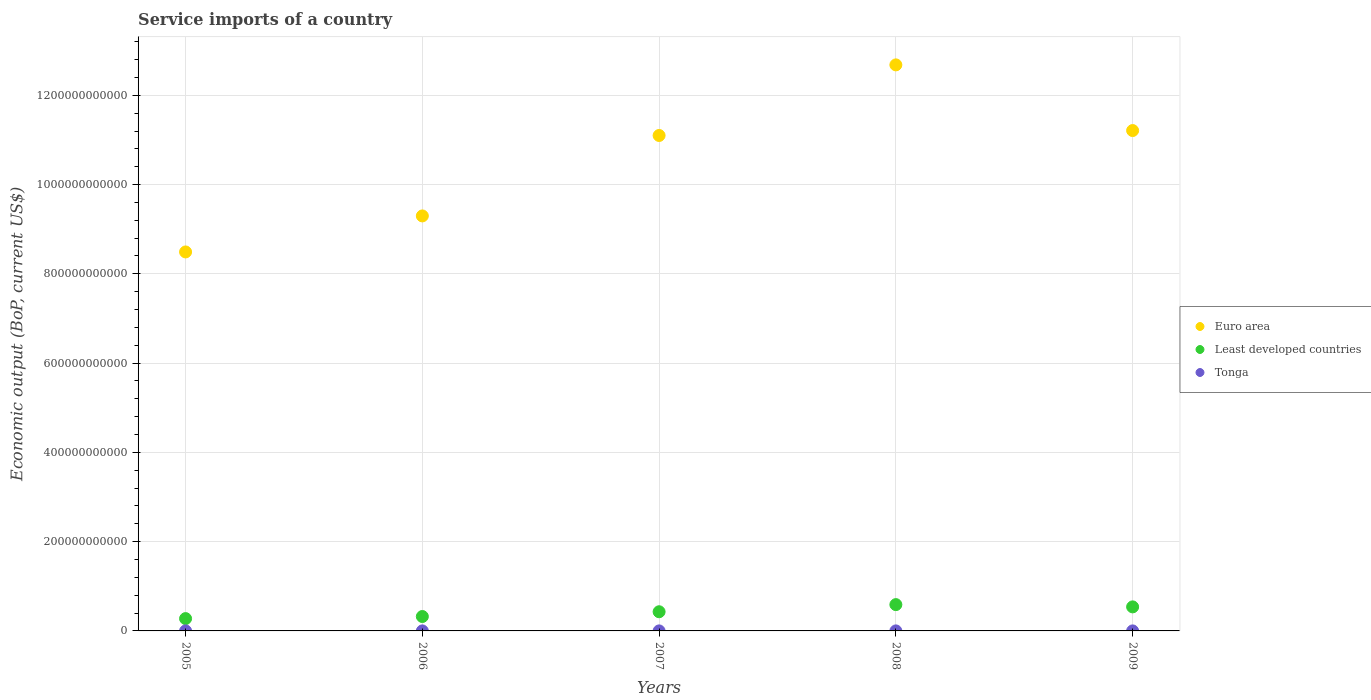What is the service imports in Tonga in 2006?
Make the answer very short. 3.78e+07. Across all years, what is the maximum service imports in Least developed countries?
Your answer should be very brief. 5.89e+1. Across all years, what is the minimum service imports in Least developed countries?
Make the answer very short. 2.76e+1. What is the total service imports in Euro area in the graph?
Offer a terse response. 5.28e+12. What is the difference between the service imports in Euro area in 2005 and that in 2009?
Your answer should be compact. -2.72e+11. What is the difference between the service imports in Euro area in 2006 and the service imports in Tonga in 2008?
Offer a very short reply. 9.30e+11. What is the average service imports in Tonga per year?
Keep it short and to the point. 4.65e+07. In the year 2009, what is the difference between the service imports in Euro area and service imports in Least developed countries?
Your answer should be compact. 1.07e+12. What is the ratio of the service imports in Least developed countries in 2005 to that in 2009?
Keep it short and to the point. 0.51. What is the difference between the highest and the second highest service imports in Euro area?
Offer a very short reply. 1.47e+11. What is the difference between the highest and the lowest service imports in Least developed countries?
Make the answer very short. 3.13e+1. In how many years, is the service imports in Euro area greater than the average service imports in Euro area taken over all years?
Make the answer very short. 3. Is the sum of the service imports in Euro area in 2005 and 2007 greater than the maximum service imports in Least developed countries across all years?
Offer a very short reply. Yes. Does the service imports in Euro area monotonically increase over the years?
Provide a succinct answer. No. Is the service imports in Tonga strictly greater than the service imports in Euro area over the years?
Offer a terse response. No. Is the service imports in Least developed countries strictly less than the service imports in Tonga over the years?
Keep it short and to the point. No. How many dotlines are there?
Your response must be concise. 3. How many years are there in the graph?
Provide a succinct answer. 5. What is the difference between two consecutive major ticks on the Y-axis?
Keep it short and to the point. 2.00e+11. Does the graph contain grids?
Your response must be concise. Yes. Where does the legend appear in the graph?
Keep it short and to the point. Center right. How many legend labels are there?
Give a very brief answer. 3. What is the title of the graph?
Offer a very short reply. Service imports of a country. What is the label or title of the Y-axis?
Offer a terse response. Economic output (BoP, current US$). What is the Economic output (BoP, current US$) of Euro area in 2005?
Your answer should be compact. 8.49e+11. What is the Economic output (BoP, current US$) of Least developed countries in 2005?
Ensure brevity in your answer.  2.76e+1. What is the Economic output (BoP, current US$) of Tonga in 2005?
Offer a very short reply. 4.01e+07. What is the Economic output (BoP, current US$) in Euro area in 2006?
Your answer should be compact. 9.30e+11. What is the Economic output (BoP, current US$) of Least developed countries in 2006?
Your response must be concise. 3.23e+1. What is the Economic output (BoP, current US$) in Tonga in 2006?
Make the answer very short. 3.78e+07. What is the Economic output (BoP, current US$) of Euro area in 2007?
Ensure brevity in your answer.  1.11e+12. What is the Economic output (BoP, current US$) in Least developed countries in 2007?
Your answer should be very brief. 4.30e+1. What is the Economic output (BoP, current US$) of Tonga in 2007?
Make the answer very short. 4.46e+07. What is the Economic output (BoP, current US$) in Euro area in 2008?
Keep it short and to the point. 1.27e+12. What is the Economic output (BoP, current US$) of Least developed countries in 2008?
Your answer should be compact. 5.89e+1. What is the Economic output (BoP, current US$) in Tonga in 2008?
Offer a terse response. 5.90e+07. What is the Economic output (BoP, current US$) of Euro area in 2009?
Ensure brevity in your answer.  1.12e+12. What is the Economic output (BoP, current US$) in Least developed countries in 2009?
Provide a short and direct response. 5.39e+1. What is the Economic output (BoP, current US$) in Tonga in 2009?
Offer a terse response. 5.08e+07. Across all years, what is the maximum Economic output (BoP, current US$) in Euro area?
Keep it short and to the point. 1.27e+12. Across all years, what is the maximum Economic output (BoP, current US$) in Least developed countries?
Keep it short and to the point. 5.89e+1. Across all years, what is the maximum Economic output (BoP, current US$) of Tonga?
Ensure brevity in your answer.  5.90e+07. Across all years, what is the minimum Economic output (BoP, current US$) in Euro area?
Your answer should be very brief. 8.49e+11. Across all years, what is the minimum Economic output (BoP, current US$) of Least developed countries?
Keep it short and to the point. 2.76e+1. Across all years, what is the minimum Economic output (BoP, current US$) of Tonga?
Your answer should be very brief. 3.78e+07. What is the total Economic output (BoP, current US$) in Euro area in the graph?
Ensure brevity in your answer.  5.28e+12. What is the total Economic output (BoP, current US$) in Least developed countries in the graph?
Your answer should be very brief. 2.16e+11. What is the total Economic output (BoP, current US$) of Tonga in the graph?
Offer a terse response. 2.32e+08. What is the difference between the Economic output (BoP, current US$) in Euro area in 2005 and that in 2006?
Provide a succinct answer. -8.07e+1. What is the difference between the Economic output (BoP, current US$) in Least developed countries in 2005 and that in 2006?
Offer a very short reply. -4.66e+09. What is the difference between the Economic output (BoP, current US$) in Tonga in 2005 and that in 2006?
Give a very brief answer. 2.22e+06. What is the difference between the Economic output (BoP, current US$) in Euro area in 2005 and that in 2007?
Keep it short and to the point. -2.61e+11. What is the difference between the Economic output (BoP, current US$) of Least developed countries in 2005 and that in 2007?
Provide a succinct answer. -1.53e+1. What is the difference between the Economic output (BoP, current US$) of Tonga in 2005 and that in 2007?
Ensure brevity in your answer.  -4.55e+06. What is the difference between the Economic output (BoP, current US$) in Euro area in 2005 and that in 2008?
Ensure brevity in your answer.  -4.19e+11. What is the difference between the Economic output (BoP, current US$) in Least developed countries in 2005 and that in 2008?
Offer a very short reply. -3.13e+1. What is the difference between the Economic output (BoP, current US$) of Tonga in 2005 and that in 2008?
Offer a terse response. -1.89e+07. What is the difference between the Economic output (BoP, current US$) of Euro area in 2005 and that in 2009?
Keep it short and to the point. -2.72e+11. What is the difference between the Economic output (BoP, current US$) in Least developed countries in 2005 and that in 2009?
Ensure brevity in your answer.  -2.62e+1. What is the difference between the Economic output (BoP, current US$) in Tonga in 2005 and that in 2009?
Keep it short and to the point. -1.07e+07. What is the difference between the Economic output (BoP, current US$) in Euro area in 2006 and that in 2007?
Your response must be concise. -1.80e+11. What is the difference between the Economic output (BoP, current US$) in Least developed countries in 2006 and that in 2007?
Make the answer very short. -1.07e+1. What is the difference between the Economic output (BoP, current US$) in Tonga in 2006 and that in 2007?
Provide a short and direct response. -6.76e+06. What is the difference between the Economic output (BoP, current US$) in Euro area in 2006 and that in 2008?
Ensure brevity in your answer.  -3.38e+11. What is the difference between the Economic output (BoP, current US$) in Least developed countries in 2006 and that in 2008?
Give a very brief answer. -2.67e+1. What is the difference between the Economic output (BoP, current US$) of Tonga in 2006 and that in 2008?
Your answer should be very brief. -2.12e+07. What is the difference between the Economic output (BoP, current US$) of Euro area in 2006 and that in 2009?
Ensure brevity in your answer.  -1.91e+11. What is the difference between the Economic output (BoP, current US$) in Least developed countries in 2006 and that in 2009?
Keep it short and to the point. -2.16e+1. What is the difference between the Economic output (BoP, current US$) in Tonga in 2006 and that in 2009?
Your answer should be very brief. -1.29e+07. What is the difference between the Economic output (BoP, current US$) of Euro area in 2007 and that in 2008?
Your answer should be very brief. -1.58e+11. What is the difference between the Economic output (BoP, current US$) of Least developed countries in 2007 and that in 2008?
Offer a very short reply. -1.60e+1. What is the difference between the Economic output (BoP, current US$) of Tonga in 2007 and that in 2008?
Your answer should be very brief. -1.44e+07. What is the difference between the Economic output (BoP, current US$) in Euro area in 2007 and that in 2009?
Provide a succinct answer. -1.10e+1. What is the difference between the Economic output (BoP, current US$) in Least developed countries in 2007 and that in 2009?
Make the answer very short. -1.09e+1. What is the difference between the Economic output (BoP, current US$) of Tonga in 2007 and that in 2009?
Your answer should be compact. -6.15e+06. What is the difference between the Economic output (BoP, current US$) in Euro area in 2008 and that in 2009?
Ensure brevity in your answer.  1.47e+11. What is the difference between the Economic output (BoP, current US$) of Least developed countries in 2008 and that in 2009?
Your response must be concise. 5.08e+09. What is the difference between the Economic output (BoP, current US$) of Tonga in 2008 and that in 2009?
Provide a succinct answer. 8.25e+06. What is the difference between the Economic output (BoP, current US$) in Euro area in 2005 and the Economic output (BoP, current US$) in Least developed countries in 2006?
Ensure brevity in your answer.  8.17e+11. What is the difference between the Economic output (BoP, current US$) of Euro area in 2005 and the Economic output (BoP, current US$) of Tonga in 2006?
Your response must be concise. 8.49e+11. What is the difference between the Economic output (BoP, current US$) in Least developed countries in 2005 and the Economic output (BoP, current US$) in Tonga in 2006?
Your response must be concise. 2.76e+1. What is the difference between the Economic output (BoP, current US$) in Euro area in 2005 and the Economic output (BoP, current US$) in Least developed countries in 2007?
Your response must be concise. 8.06e+11. What is the difference between the Economic output (BoP, current US$) in Euro area in 2005 and the Economic output (BoP, current US$) in Tonga in 2007?
Offer a terse response. 8.49e+11. What is the difference between the Economic output (BoP, current US$) in Least developed countries in 2005 and the Economic output (BoP, current US$) in Tonga in 2007?
Your response must be concise. 2.76e+1. What is the difference between the Economic output (BoP, current US$) of Euro area in 2005 and the Economic output (BoP, current US$) of Least developed countries in 2008?
Offer a terse response. 7.90e+11. What is the difference between the Economic output (BoP, current US$) of Euro area in 2005 and the Economic output (BoP, current US$) of Tonga in 2008?
Offer a very short reply. 8.49e+11. What is the difference between the Economic output (BoP, current US$) of Least developed countries in 2005 and the Economic output (BoP, current US$) of Tonga in 2008?
Provide a short and direct response. 2.75e+1. What is the difference between the Economic output (BoP, current US$) in Euro area in 2005 and the Economic output (BoP, current US$) in Least developed countries in 2009?
Give a very brief answer. 7.95e+11. What is the difference between the Economic output (BoP, current US$) in Euro area in 2005 and the Economic output (BoP, current US$) in Tonga in 2009?
Provide a succinct answer. 8.49e+11. What is the difference between the Economic output (BoP, current US$) in Least developed countries in 2005 and the Economic output (BoP, current US$) in Tonga in 2009?
Your answer should be compact. 2.76e+1. What is the difference between the Economic output (BoP, current US$) in Euro area in 2006 and the Economic output (BoP, current US$) in Least developed countries in 2007?
Offer a terse response. 8.87e+11. What is the difference between the Economic output (BoP, current US$) of Euro area in 2006 and the Economic output (BoP, current US$) of Tonga in 2007?
Your response must be concise. 9.30e+11. What is the difference between the Economic output (BoP, current US$) in Least developed countries in 2006 and the Economic output (BoP, current US$) in Tonga in 2007?
Provide a succinct answer. 3.22e+1. What is the difference between the Economic output (BoP, current US$) in Euro area in 2006 and the Economic output (BoP, current US$) in Least developed countries in 2008?
Provide a short and direct response. 8.71e+11. What is the difference between the Economic output (BoP, current US$) in Euro area in 2006 and the Economic output (BoP, current US$) in Tonga in 2008?
Offer a very short reply. 9.30e+11. What is the difference between the Economic output (BoP, current US$) in Least developed countries in 2006 and the Economic output (BoP, current US$) in Tonga in 2008?
Give a very brief answer. 3.22e+1. What is the difference between the Economic output (BoP, current US$) in Euro area in 2006 and the Economic output (BoP, current US$) in Least developed countries in 2009?
Your answer should be very brief. 8.76e+11. What is the difference between the Economic output (BoP, current US$) in Euro area in 2006 and the Economic output (BoP, current US$) in Tonga in 2009?
Offer a terse response. 9.30e+11. What is the difference between the Economic output (BoP, current US$) in Least developed countries in 2006 and the Economic output (BoP, current US$) in Tonga in 2009?
Your answer should be very brief. 3.22e+1. What is the difference between the Economic output (BoP, current US$) of Euro area in 2007 and the Economic output (BoP, current US$) of Least developed countries in 2008?
Provide a succinct answer. 1.05e+12. What is the difference between the Economic output (BoP, current US$) in Euro area in 2007 and the Economic output (BoP, current US$) in Tonga in 2008?
Your response must be concise. 1.11e+12. What is the difference between the Economic output (BoP, current US$) of Least developed countries in 2007 and the Economic output (BoP, current US$) of Tonga in 2008?
Keep it short and to the point. 4.29e+1. What is the difference between the Economic output (BoP, current US$) of Euro area in 2007 and the Economic output (BoP, current US$) of Least developed countries in 2009?
Your answer should be compact. 1.06e+12. What is the difference between the Economic output (BoP, current US$) in Euro area in 2007 and the Economic output (BoP, current US$) in Tonga in 2009?
Ensure brevity in your answer.  1.11e+12. What is the difference between the Economic output (BoP, current US$) of Least developed countries in 2007 and the Economic output (BoP, current US$) of Tonga in 2009?
Your response must be concise. 4.29e+1. What is the difference between the Economic output (BoP, current US$) in Euro area in 2008 and the Economic output (BoP, current US$) in Least developed countries in 2009?
Keep it short and to the point. 1.21e+12. What is the difference between the Economic output (BoP, current US$) in Euro area in 2008 and the Economic output (BoP, current US$) in Tonga in 2009?
Give a very brief answer. 1.27e+12. What is the difference between the Economic output (BoP, current US$) in Least developed countries in 2008 and the Economic output (BoP, current US$) in Tonga in 2009?
Offer a very short reply. 5.89e+1. What is the average Economic output (BoP, current US$) of Euro area per year?
Provide a succinct answer. 1.06e+12. What is the average Economic output (BoP, current US$) of Least developed countries per year?
Your answer should be compact. 4.31e+1. What is the average Economic output (BoP, current US$) of Tonga per year?
Provide a short and direct response. 4.65e+07. In the year 2005, what is the difference between the Economic output (BoP, current US$) of Euro area and Economic output (BoP, current US$) of Least developed countries?
Make the answer very short. 8.21e+11. In the year 2005, what is the difference between the Economic output (BoP, current US$) of Euro area and Economic output (BoP, current US$) of Tonga?
Ensure brevity in your answer.  8.49e+11. In the year 2005, what is the difference between the Economic output (BoP, current US$) in Least developed countries and Economic output (BoP, current US$) in Tonga?
Your answer should be very brief. 2.76e+1. In the year 2006, what is the difference between the Economic output (BoP, current US$) in Euro area and Economic output (BoP, current US$) in Least developed countries?
Make the answer very short. 8.98e+11. In the year 2006, what is the difference between the Economic output (BoP, current US$) of Euro area and Economic output (BoP, current US$) of Tonga?
Your response must be concise. 9.30e+11. In the year 2006, what is the difference between the Economic output (BoP, current US$) of Least developed countries and Economic output (BoP, current US$) of Tonga?
Make the answer very short. 3.22e+1. In the year 2007, what is the difference between the Economic output (BoP, current US$) of Euro area and Economic output (BoP, current US$) of Least developed countries?
Your answer should be very brief. 1.07e+12. In the year 2007, what is the difference between the Economic output (BoP, current US$) in Euro area and Economic output (BoP, current US$) in Tonga?
Your answer should be compact. 1.11e+12. In the year 2007, what is the difference between the Economic output (BoP, current US$) of Least developed countries and Economic output (BoP, current US$) of Tonga?
Your response must be concise. 4.29e+1. In the year 2008, what is the difference between the Economic output (BoP, current US$) in Euro area and Economic output (BoP, current US$) in Least developed countries?
Your response must be concise. 1.21e+12. In the year 2008, what is the difference between the Economic output (BoP, current US$) of Euro area and Economic output (BoP, current US$) of Tonga?
Offer a very short reply. 1.27e+12. In the year 2008, what is the difference between the Economic output (BoP, current US$) of Least developed countries and Economic output (BoP, current US$) of Tonga?
Your response must be concise. 5.89e+1. In the year 2009, what is the difference between the Economic output (BoP, current US$) of Euro area and Economic output (BoP, current US$) of Least developed countries?
Provide a short and direct response. 1.07e+12. In the year 2009, what is the difference between the Economic output (BoP, current US$) of Euro area and Economic output (BoP, current US$) of Tonga?
Your response must be concise. 1.12e+12. In the year 2009, what is the difference between the Economic output (BoP, current US$) in Least developed countries and Economic output (BoP, current US$) in Tonga?
Give a very brief answer. 5.38e+1. What is the ratio of the Economic output (BoP, current US$) of Euro area in 2005 to that in 2006?
Ensure brevity in your answer.  0.91. What is the ratio of the Economic output (BoP, current US$) of Least developed countries in 2005 to that in 2006?
Make the answer very short. 0.86. What is the ratio of the Economic output (BoP, current US$) in Tonga in 2005 to that in 2006?
Your answer should be very brief. 1.06. What is the ratio of the Economic output (BoP, current US$) in Euro area in 2005 to that in 2007?
Offer a terse response. 0.76. What is the ratio of the Economic output (BoP, current US$) of Least developed countries in 2005 to that in 2007?
Your response must be concise. 0.64. What is the ratio of the Economic output (BoP, current US$) in Tonga in 2005 to that in 2007?
Offer a very short reply. 0.9. What is the ratio of the Economic output (BoP, current US$) in Euro area in 2005 to that in 2008?
Ensure brevity in your answer.  0.67. What is the ratio of the Economic output (BoP, current US$) in Least developed countries in 2005 to that in 2008?
Your answer should be very brief. 0.47. What is the ratio of the Economic output (BoP, current US$) in Tonga in 2005 to that in 2008?
Give a very brief answer. 0.68. What is the ratio of the Economic output (BoP, current US$) in Euro area in 2005 to that in 2009?
Give a very brief answer. 0.76. What is the ratio of the Economic output (BoP, current US$) in Least developed countries in 2005 to that in 2009?
Your response must be concise. 0.51. What is the ratio of the Economic output (BoP, current US$) of Tonga in 2005 to that in 2009?
Your answer should be very brief. 0.79. What is the ratio of the Economic output (BoP, current US$) in Euro area in 2006 to that in 2007?
Provide a short and direct response. 0.84. What is the ratio of the Economic output (BoP, current US$) in Least developed countries in 2006 to that in 2007?
Ensure brevity in your answer.  0.75. What is the ratio of the Economic output (BoP, current US$) of Tonga in 2006 to that in 2007?
Your response must be concise. 0.85. What is the ratio of the Economic output (BoP, current US$) in Euro area in 2006 to that in 2008?
Give a very brief answer. 0.73. What is the ratio of the Economic output (BoP, current US$) of Least developed countries in 2006 to that in 2008?
Give a very brief answer. 0.55. What is the ratio of the Economic output (BoP, current US$) of Tonga in 2006 to that in 2008?
Offer a very short reply. 0.64. What is the ratio of the Economic output (BoP, current US$) in Euro area in 2006 to that in 2009?
Give a very brief answer. 0.83. What is the ratio of the Economic output (BoP, current US$) in Least developed countries in 2006 to that in 2009?
Your answer should be compact. 0.6. What is the ratio of the Economic output (BoP, current US$) in Tonga in 2006 to that in 2009?
Make the answer very short. 0.75. What is the ratio of the Economic output (BoP, current US$) of Euro area in 2007 to that in 2008?
Give a very brief answer. 0.88. What is the ratio of the Economic output (BoP, current US$) of Least developed countries in 2007 to that in 2008?
Offer a terse response. 0.73. What is the ratio of the Economic output (BoP, current US$) of Tonga in 2007 to that in 2008?
Your answer should be compact. 0.76. What is the ratio of the Economic output (BoP, current US$) of Least developed countries in 2007 to that in 2009?
Your answer should be compact. 0.8. What is the ratio of the Economic output (BoP, current US$) in Tonga in 2007 to that in 2009?
Your response must be concise. 0.88. What is the ratio of the Economic output (BoP, current US$) of Euro area in 2008 to that in 2009?
Your answer should be compact. 1.13. What is the ratio of the Economic output (BoP, current US$) of Least developed countries in 2008 to that in 2009?
Provide a succinct answer. 1.09. What is the ratio of the Economic output (BoP, current US$) in Tonga in 2008 to that in 2009?
Make the answer very short. 1.16. What is the difference between the highest and the second highest Economic output (BoP, current US$) of Euro area?
Your answer should be compact. 1.47e+11. What is the difference between the highest and the second highest Economic output (BoP, current US$) of Least developed countries?
Your answer should be compact. 5.08e+09. What is the difference between the highest and the second highest Economic output (BoP, current US$) in Tonga?
Your answer should be compact. 8.25e+06. What is the difference between the highest and the lowest Economic output (BoP, current US$) in Euro area?
Make the answer very short. 4.19e+11. What is the difference between the highest and the lowest Economic output (BoP, current US$) in Least developed countries?
Ensure brevity in your answer.  3.13e+1. What is the difference between the highest and the lowest Economic output (BoP, current US$) in Tonga?
Keep it short and to the point. 2.12e+07. 